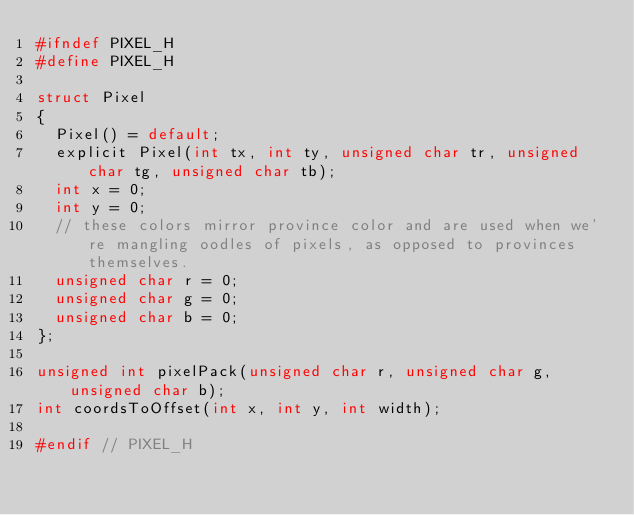<code> <loc_0><loc_0><loc_500><loc_500><_C_>#ifndef PIXEL_H
#define PIXEL_H

struct Pixel
{
	Pixel() = default;
	explicit Pixel(int tx, int ty, unsigned char tr, unsigned char tg, unsigned char tb);
	int x = 0;
	int y = 0;
	// these colors mirror province color and are used when we're mangling oodles of pixels, as opposed to provinces themselves.
	unsigned char r = 0;
	unsigned char g = 0;
	unsigned char b = 0;
};

unsigned int pixelPack(unsigned char r, unsigned char g, unsigned char b);
int coordsToOffset(int x, int y, int width);

#endif // PIXEL_H
</code> 